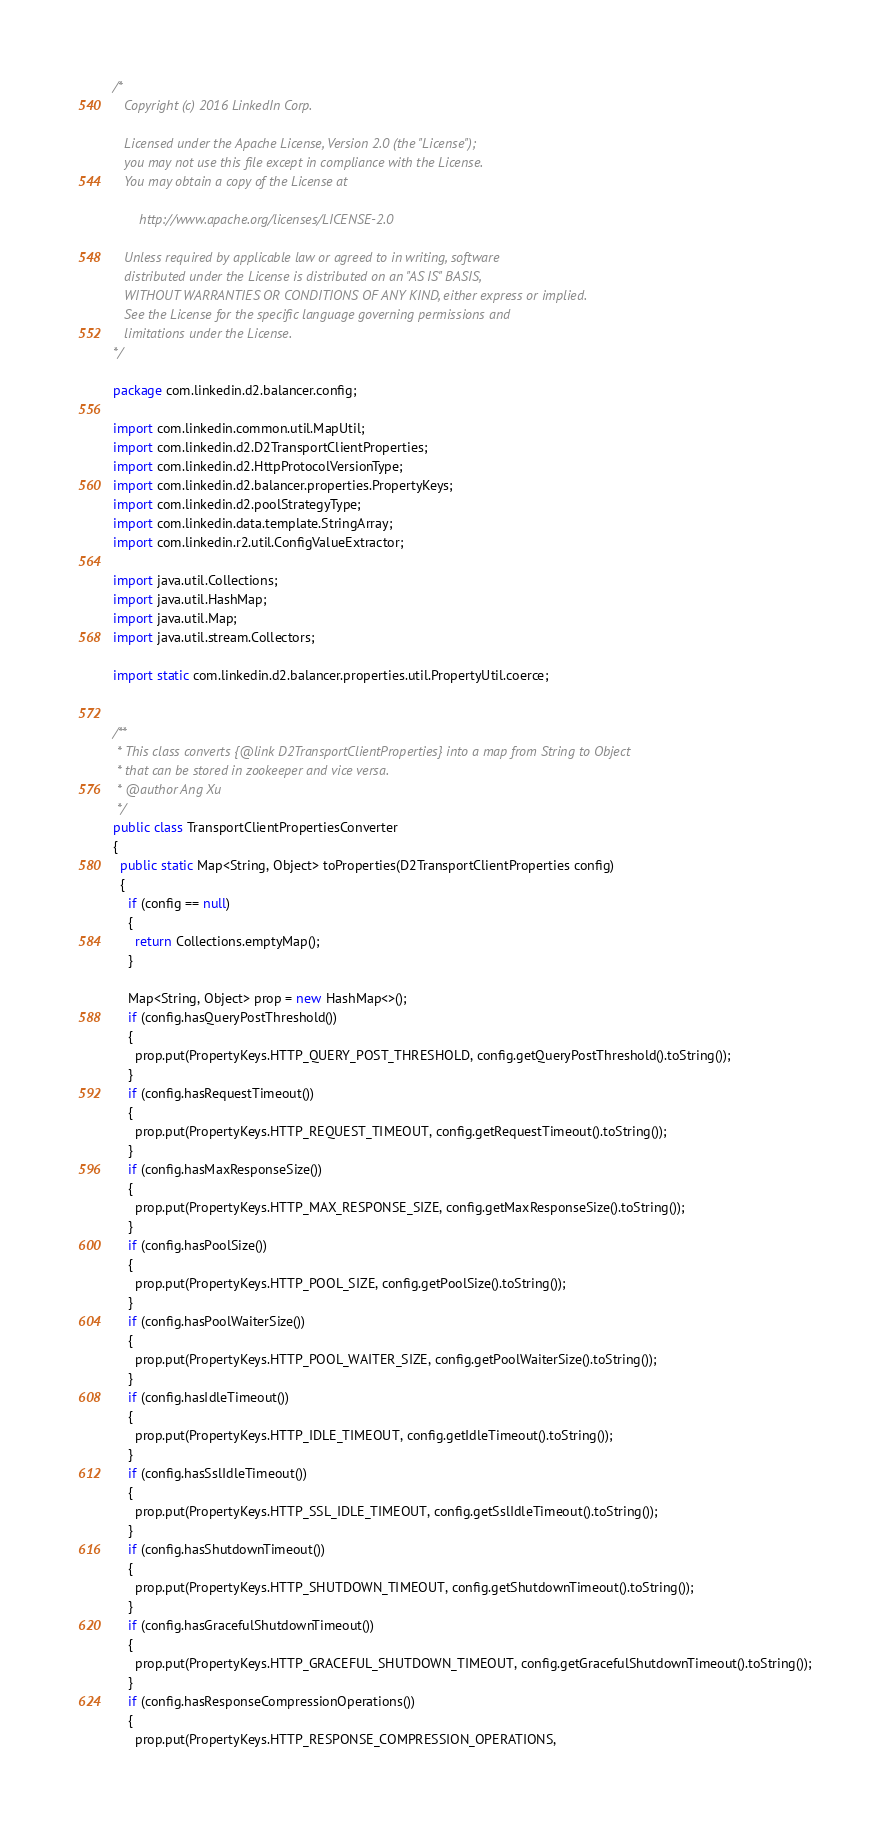<code> <loc_0><loc_0><loc_500><loc_500><_Java_>/*
   Copyright (c) 2016 LinkedIn Corp.

   Licensed under the Apache License, Version 2.0 (the "License");
   you may not use this file except in compliance with the License.
   You may obtain a copy of the License at

       http://www.apache.org/licenses/LICENSE-2.0

   Unless required by applicable law or agreed to in writing, software
   distributed under the License is distributed on an "AS IS" BASIS,
   WITHOUT WARRANTIES OR CONDITIONS OF ANY KIND, either express or implied.
   See the License for the specific language governing permissions and
   limitations under the License.
*/

package com.linkedin.d2.balancer.config;

import com.linkedin.common.util.MapUtil;
import com.linkedin.d2.D2TransportClientProperties;
import com.linkedin.d2.HttpProtocolVersionType;
import com.linkedin.d2.balancer.properties.PropertyKeys;
import com.linkedin.d2.poolStrategyType;
import com.linkedin.data.template.StringArray;
import com.linkedin.r2.util.ConfigValueExtractor;

import java.util.Collections;
import java.util.HashMap;
import java.util.Map;
import java.util.stream.Collectors;

import static com.linkedin.d2.balancer.properties.util.PropertyUtil.coerce;


/**
 * This class converts {@link D2TransportClientProperties} into a map from String to Object
 * that can be stored in zookeeper and vice versa.
 * @author Ang Xu
 */
public class TransportClientPropertiesConverter
{
  public static Map<String, Object> toProperties(D2TransportClientProperties config)
  {
    if (config == null)
    {
      return Collections.emptyMap();
    }

    Map<String, Object> prop = new HashMap<>();
    if (config.hasQueryPostThreshold())
    {
      prop.put(PropertyKeys.HTTP_QUERY_POST_THRESHOLD, config.getQueryPostThreshold().toString());
    }
    if (config.hasRequestTimeout())
    {
      prop.put(PropertyKeys.HTTP_REQUEST_TIMEOUT, config.getRequestTimeout().toString());
    }
    if (config.hasMaxResponseSize())
    {
      prop.put(PropertyKeys.HTTP_MAX_RESPONSE_SIZE, config.getMaxResponseSize().toString());
    }
    if (config.hasPoolSize())
    {
      prop.put(PropertyKeys.HTTP_POOL_SIZE, config.getPoolSize().toString());
    }
    if (config.hasPoolWaiterSize())
    {
      prop.put(PropertyKeys.HTTP_POOL_WAITER_SIZE, config.getPoolWaiterSize().toString());
    }
    if (config.hasIdleTimeout())
    {
      prop.put(PropertyKeys.HTTP_IDLE_TIMEOUT, config.getIdleTimeout().toString());
    }
    if (config.hasSslIdleTimeout())
    {
      prop.put(PropertyKeys.HTTP_SSL_IDLE_TIMEOUT, config.getSslIdleTimeout().toString());
    }
    if (config.hasShutdownTimeout())
    {
      prop.put(PropertyKeys.HTTP_SHUTDOWN_TIMEOUT, config.getShutdownTimeout().toString());
    }
    if (config.hasGracefulShutdownTimeout())
    {
      prop.put(PropertyKeys.HTTP_GRACEFUL_SHUTDOWN_TIMEOUT, config.getGracefulShutdownTimeout().toString());
    }
    if (config.hasResponseCompressionOperations())
    {
      prop.put(PropertyKeys.HTTP_RESPONSE_COMPRESSION_OPERATIONS,</code> 